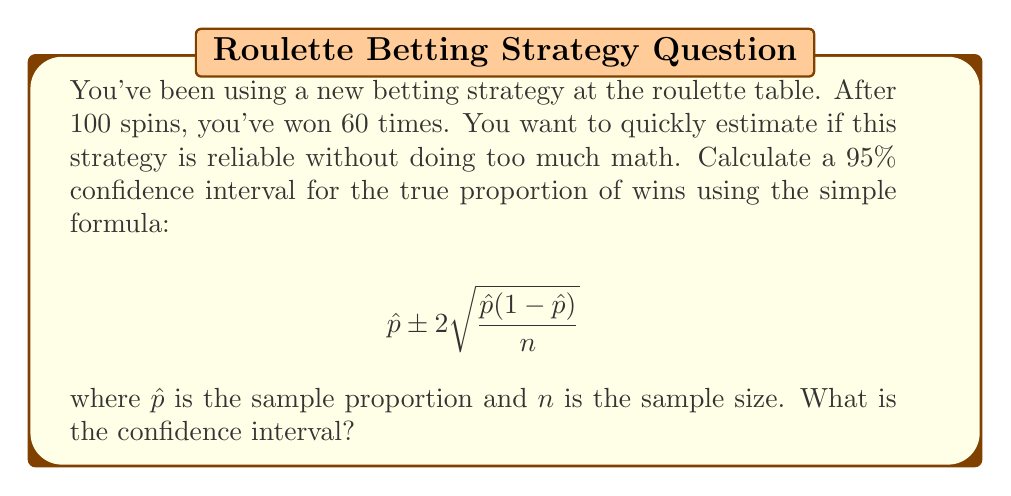Help me with this question. Let's break this down step-by-step:

1) First, we need to calculate $\hat{p}$, the sample proportion:
   $\hat{p} = \frac{\text{number of wins}}{\text{total number of spins}} = \frac{60}{100} = 0.6$

2) We know $n = 100$ (total number of spins)

3) Now, let's plug these into the formula:
   $0.6 \pm 2 \sqrt{\frac{0.6(1-0.6)}{100}}$

4) Simplify inside the square root:
   $0.6 \pm 2 \sqrt{\frac{0.6(0.4)}{100}} = 0.6 \pm 2 \sqrt{\frac{0.24}{100}}$

5) Calculate under the square root:
   $0.6 \pm 2 \sqrt{0.0024} = 0.6 \pm 2(0.049)$

6) Multiply:
   $0.6 \pm 0.098$

7) Calculate the lower and upper bounds:
   Lower: $0.6 - 0.098 = 0.502$
   Upper: $0.6 + 0.098 = 0.698$

Thus, the 95% confidence interval is (0.502, 0.698) or (50.2%, 69.8%).
Answer: (0.502, 0.698) 